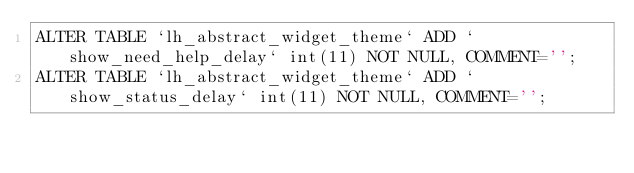Convert code to text. <code><loc_0><loc_0><loc_500><loc_500><_SQL_>ALTER TABLE `lh_abstract_widget_theme` ADD `show_need_help_delay` int(11) NOT NULL, COMMENT='';
ALTER TABLE `lh_abstract_widget_theme` ADD `show_status_delay` int(11) NOT NULL, COMMENT='';</code> 